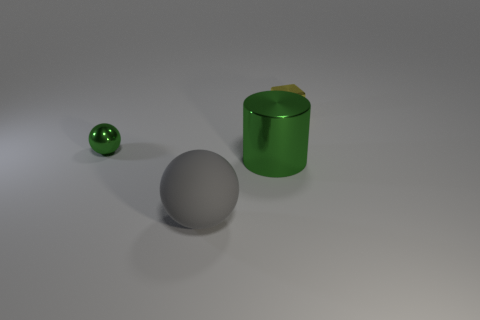Does the big cylinder have the same color as the tiny ball?
Give a very brief answer. Yes. Does the green metallic object behind the large green thing have the same size as the green metal object to the right of the gray rubber ball?
Your answer should be compact. No. Is the shape of the large shiny thing the same as the small green metal object?
Make the answer very short. No. How many things are either metallic objects in front of the small green object or small gray cubes?
Your answer should be very brief. 1. Is there a tiny green thing of the same shape as the big gray matte thing?
Make the answer very short. Yes. Are there an equal number of gray spheres that are on the right side of the tiny cube and spheres?
Offer a terse response. No. There is a large object that is the same color as the small metal sphere; what is its shape?
Ensure brevity in your answer.  Cylinder. How many things have the same size as the metallic block?
Offer a very short reply. 1. How many small cubes are right of the gray object?
Offer a terse response. 1. There is a tiny object right of the sphere to the left of the gray matte sphere; what is it made of?
Ensure brevity in your answer.  Metal. 